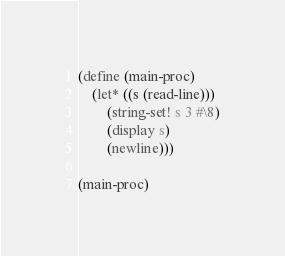Convert code to text. <code><loc_0><loc_0><loc_500><loc_500><_Scheme_>(define (main-proc)
    (let* ((s (read-line)))
        (string-set! s 3 #\8)
        (display s)
        (newline)))

(main-proc)
</code> 